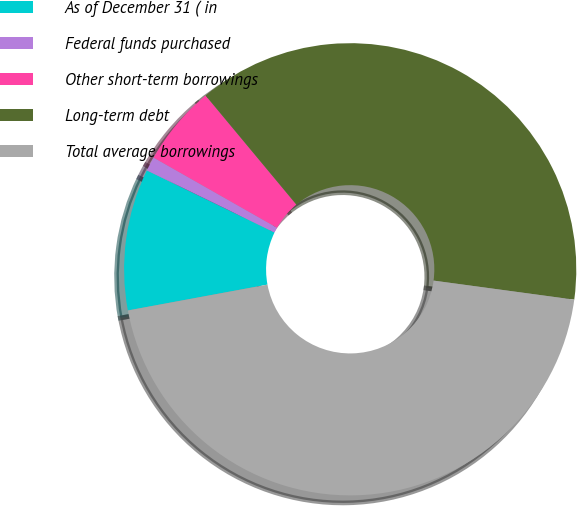Convert chart. <chart><loc_0><loc_0><loc_500><loc_500><pie_chart><fcel>As of December 31 ( in<fcel>Federal funds purchased<fcel>Other short-term borrowings<fcel>Long-term debt<fcel>Total average borrowings<nl><fcel>10.12%<fcel>1.02%<fcel>5.73%<fcel>38.19%<fcel>44.94%<nl></chart> 